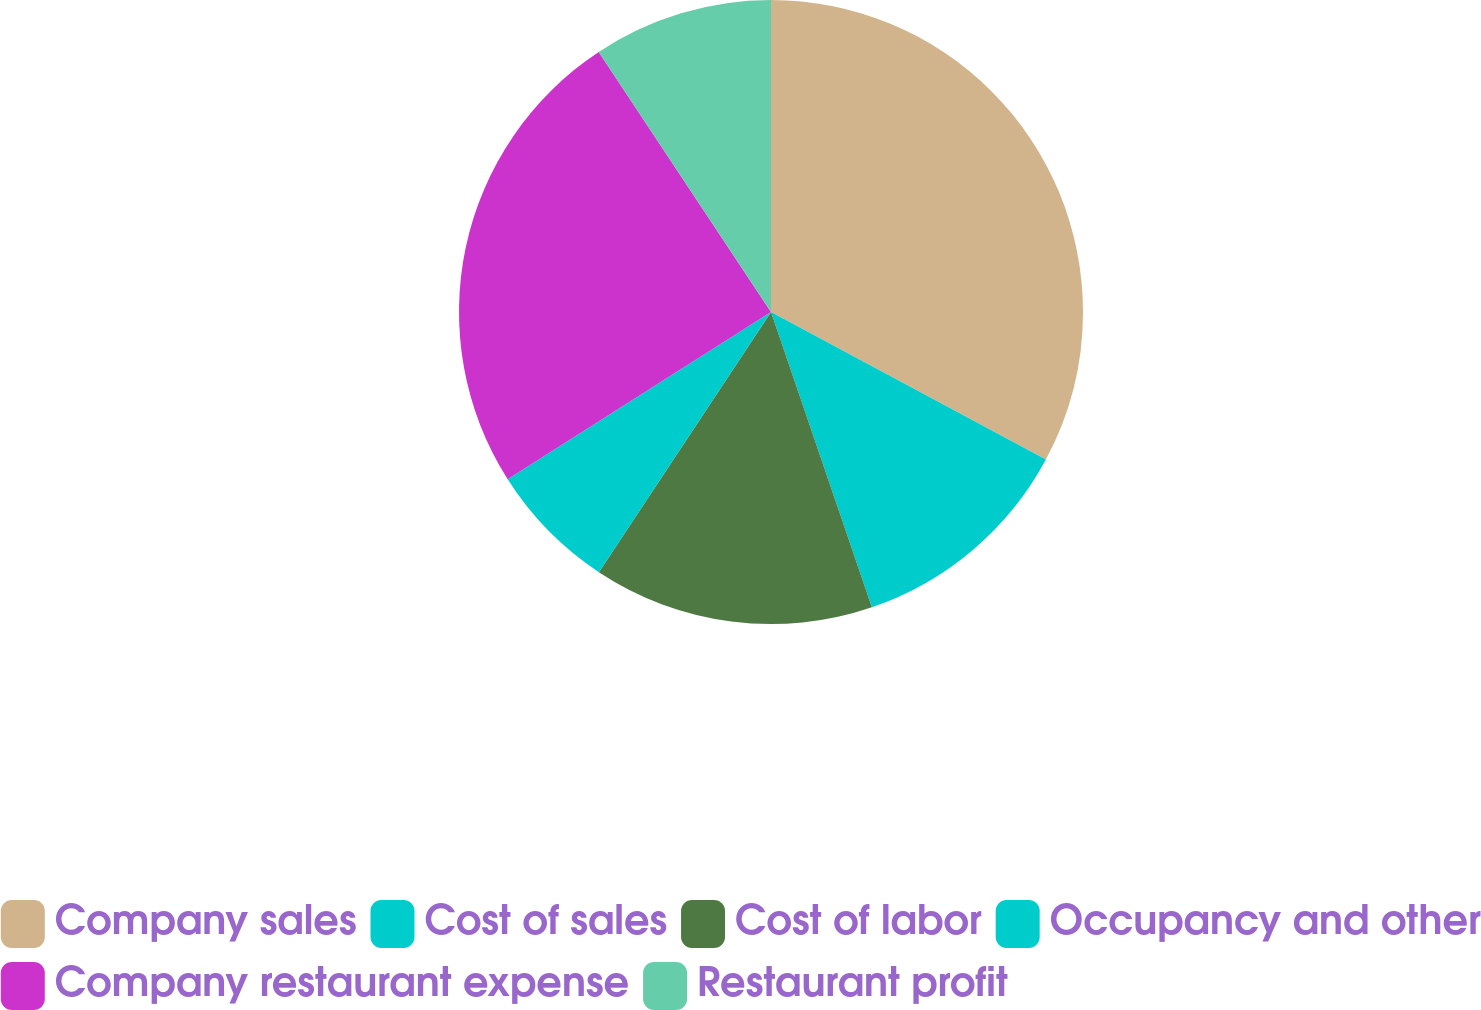<chart> <loc_0><loc_0><loc_500><loc_500><pie_chart><fcel>Company sales<fcel>Cost of sales<fcel>Cost of labor<fcel>Occupancy and other<fcel>Company restaurant expense<fcel>Restaurant profit<nl><fcel>32.84%<fcel>11.92%<fcel>14.54%<fcel>6.69%<fcel>24.7%<fcel>9.31%<nl></chart> 